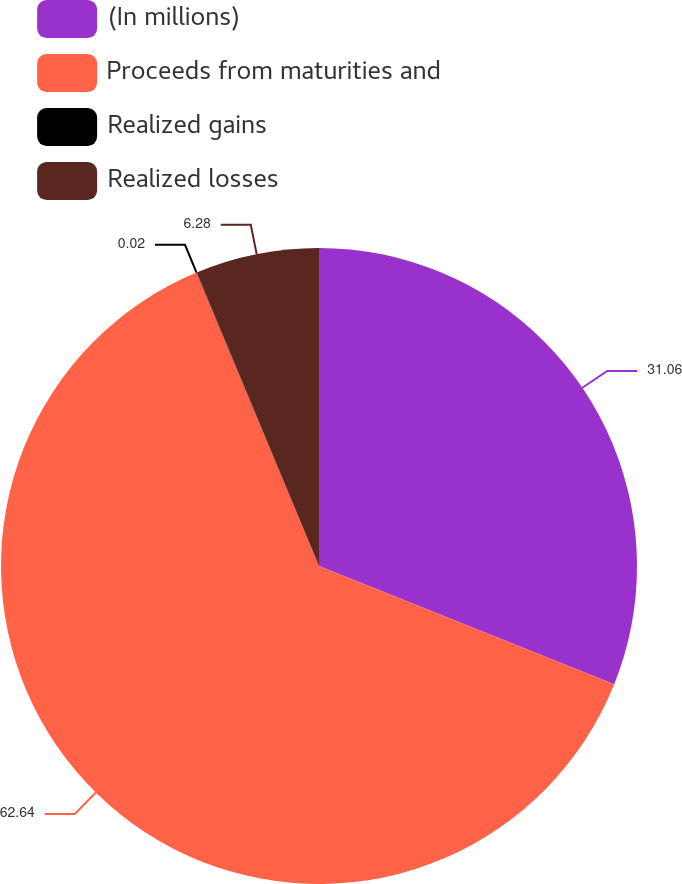Convert chart. <chart><loc_0><loc_0><loc_500><loc_500><pie_chart><fcel>(In millions)<fcel>Proceeds from maturities and<fcel>Realized gains<fcel>Realized losses<nl><fcel>31.06%<fcel>62.63%<fcel>0.02%<fcel>6.28%<nl></chart> 